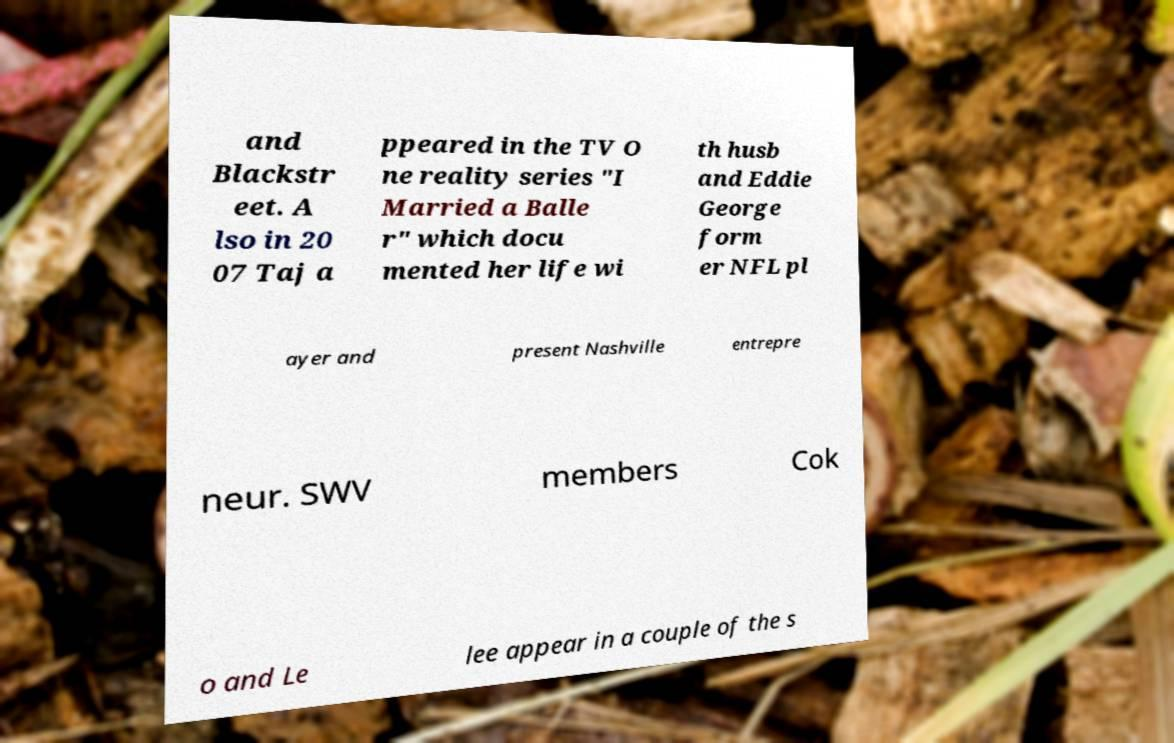Please identify and transcribe the text found in this image. and Blackstr eet. A lso in 20 07 Taj a ppeared in the TV O ne reality series "I Married a Balle r" which docu mented her life wi th husb and Eddie George form er NFL pl ayer and present Nashville entrepre neur. SWV members Cok o and Le lee appear in a couple of the s 